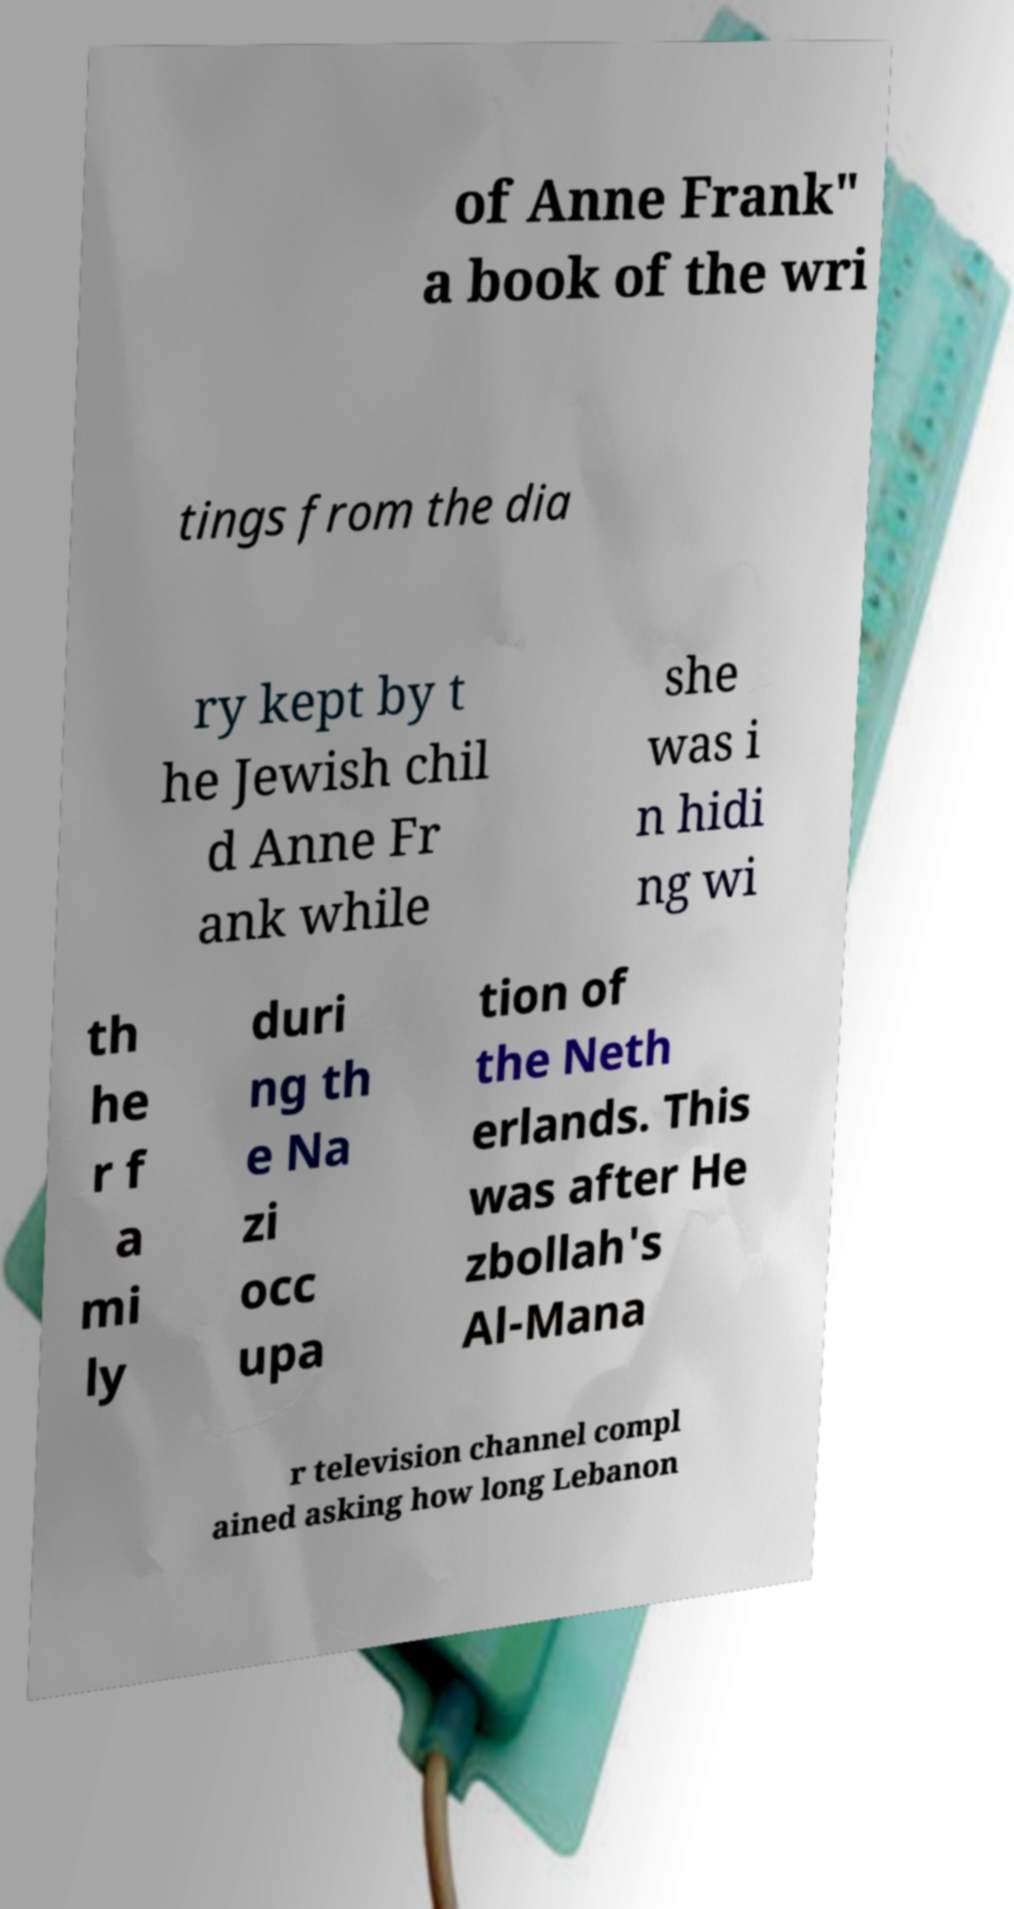Can you read and provide the text displayed in the image?This photo seems to have some interesting text. Can you extract and type it out for me? of Anne Frank" a book of the wri tings from the dia ry kept by t he Jewish chil d Anne Fr ank while she was i n hidi ng wi th he r f a mi ly duri ng th e Na zi occ upa tion of the Neth erlands. This was after He zbollah's Al-Mana r television channel compl ained asking how long Lebanon 